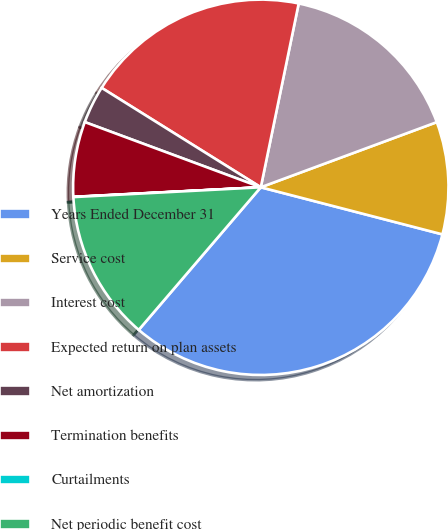Convert chart to OTSL. <chart><loc_0><loc_0><loc_500><loc_500><pie_chart><fcel>Years Ended December 31<fcel>Service cost<fcel>Interest cost<fcel>Expected return on plan assets<fcel>Net amortization<fcel>Termination benefits<fcel>Curtailments<fcel>Net periodic benefit cost<nl><fcel>32.23%<fcel>9.68%<fcel>16.12%<fcel>19.35%<fcel>3.24%<fcel>6.46%<fcel>0.02%<fcel>12.9%<nl></chart> 